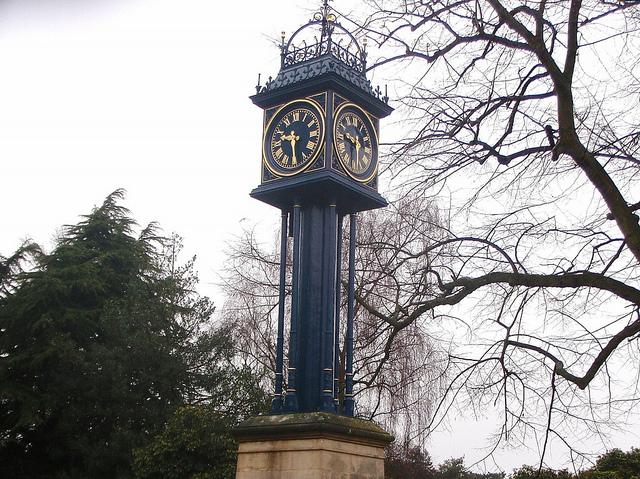Is this in London?
Keep it brief. Yes. What time is it?
Give a very brief answer. 9:30. What kind of numbers are on the clock?
Write a very short answer. Roman. 